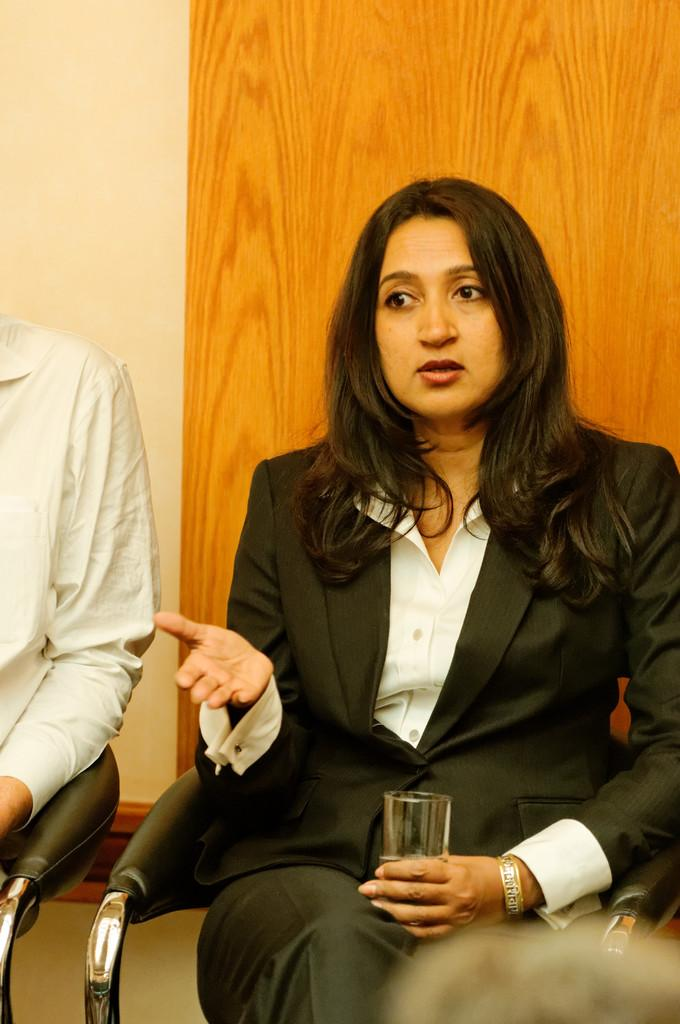Who is the main subject in the image? There is a woman in the image. What is the woman doing in the image? The woman is sitting on a chair. What is the woman holding in her hand? The woman is holding a glass with her hand. What is the woman wearing in the image? The woman is wearing a black suit. What can be seen in the background of the image? There is a wall in the background of the image. How many spiders are crawling on the woman's suit in the image? There are no spiders present in the image. What type of crowd can be seen gathering around the woman in the image? There is no crowd present in the image; it only features the woman sitting on a chair. 